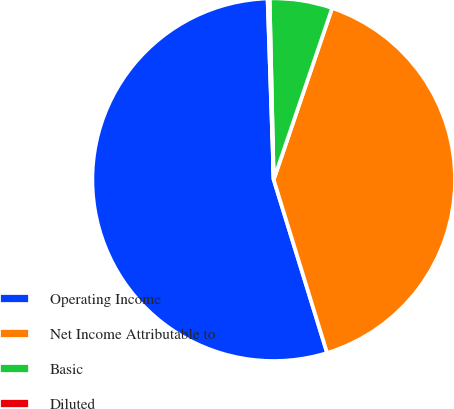<chart> <loc_0><loc_0><loc_500><loc_500><pie_chart><fcel>Operating Income<fcel>Net Income Attributable to<fcel>Basic<fcel>Diluted<nl><fcel>54.22%<fcel>40.02%<fcel>5.58%<fcel>0.18%<nl></chart> 